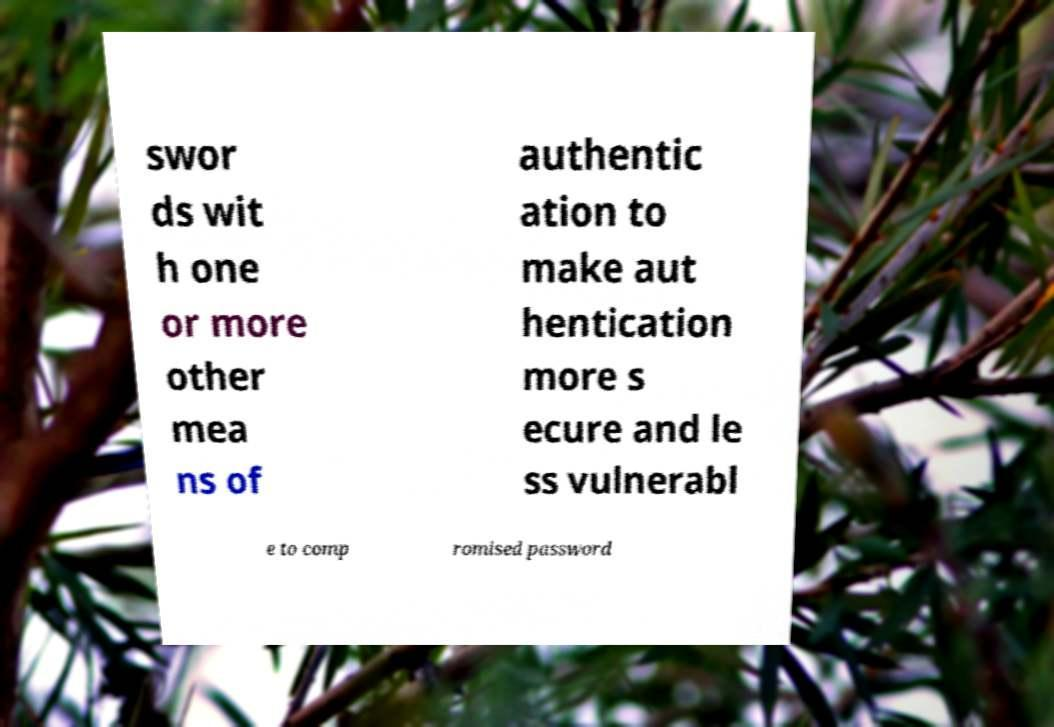Can you accurately transcribe the text from the provided image for me? swor ds wit h one or more other mea ns of authentic ation to make aut hentication more s ecure and le ss vulnerabl e to comp romised password 